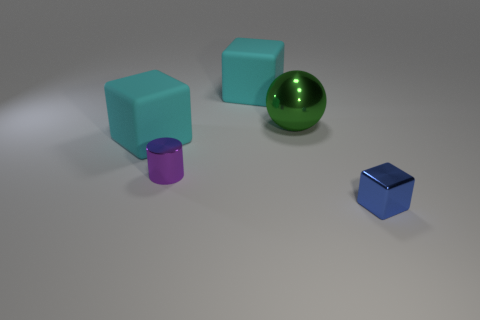Add 2 large red rubber balls. How many objects exist? 7 Subtract all spheres. How many objects are left? 4 Add 3 metallic cylinders. How many metallic cylinders are left? 4 Add 2 tiny shiny balls. How many tiny shiny balls exist? 2 Subtract 0 green cylinders. How many objects are left? 5 Subtract all big rubber blocks. Subtract all rubber blocks. How many objects are left? 1 